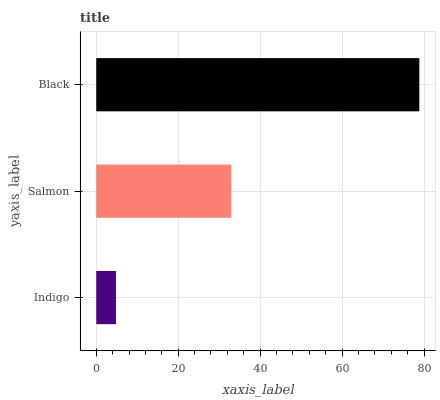Is Indigo the minimum?
Answer yes or no. Yes. Is Black the maximum?
Answer yes or no. Yes. Is Salmon the minimum?
Answer yes or no. No. Is Salmon the maximum?
Answer yes or no. No. Is Salmon greater than Indigo?
Answer yes or no. Yes. Is Indigo less than Salmon?
Answer yes or no. Yes. Is Indigo greater than Salmon?
Answer yes or no. No. Is Salmon less than Indigo?
Answer yes or no. No. Is Salmon the high median?
Answer yes or no. Yes. Is Salmon the low median?
Answer yes or no. Yes. Is Indigo the high median?
Answer yes or no. No. Is Black the low median?
Answer yes or no. No. 